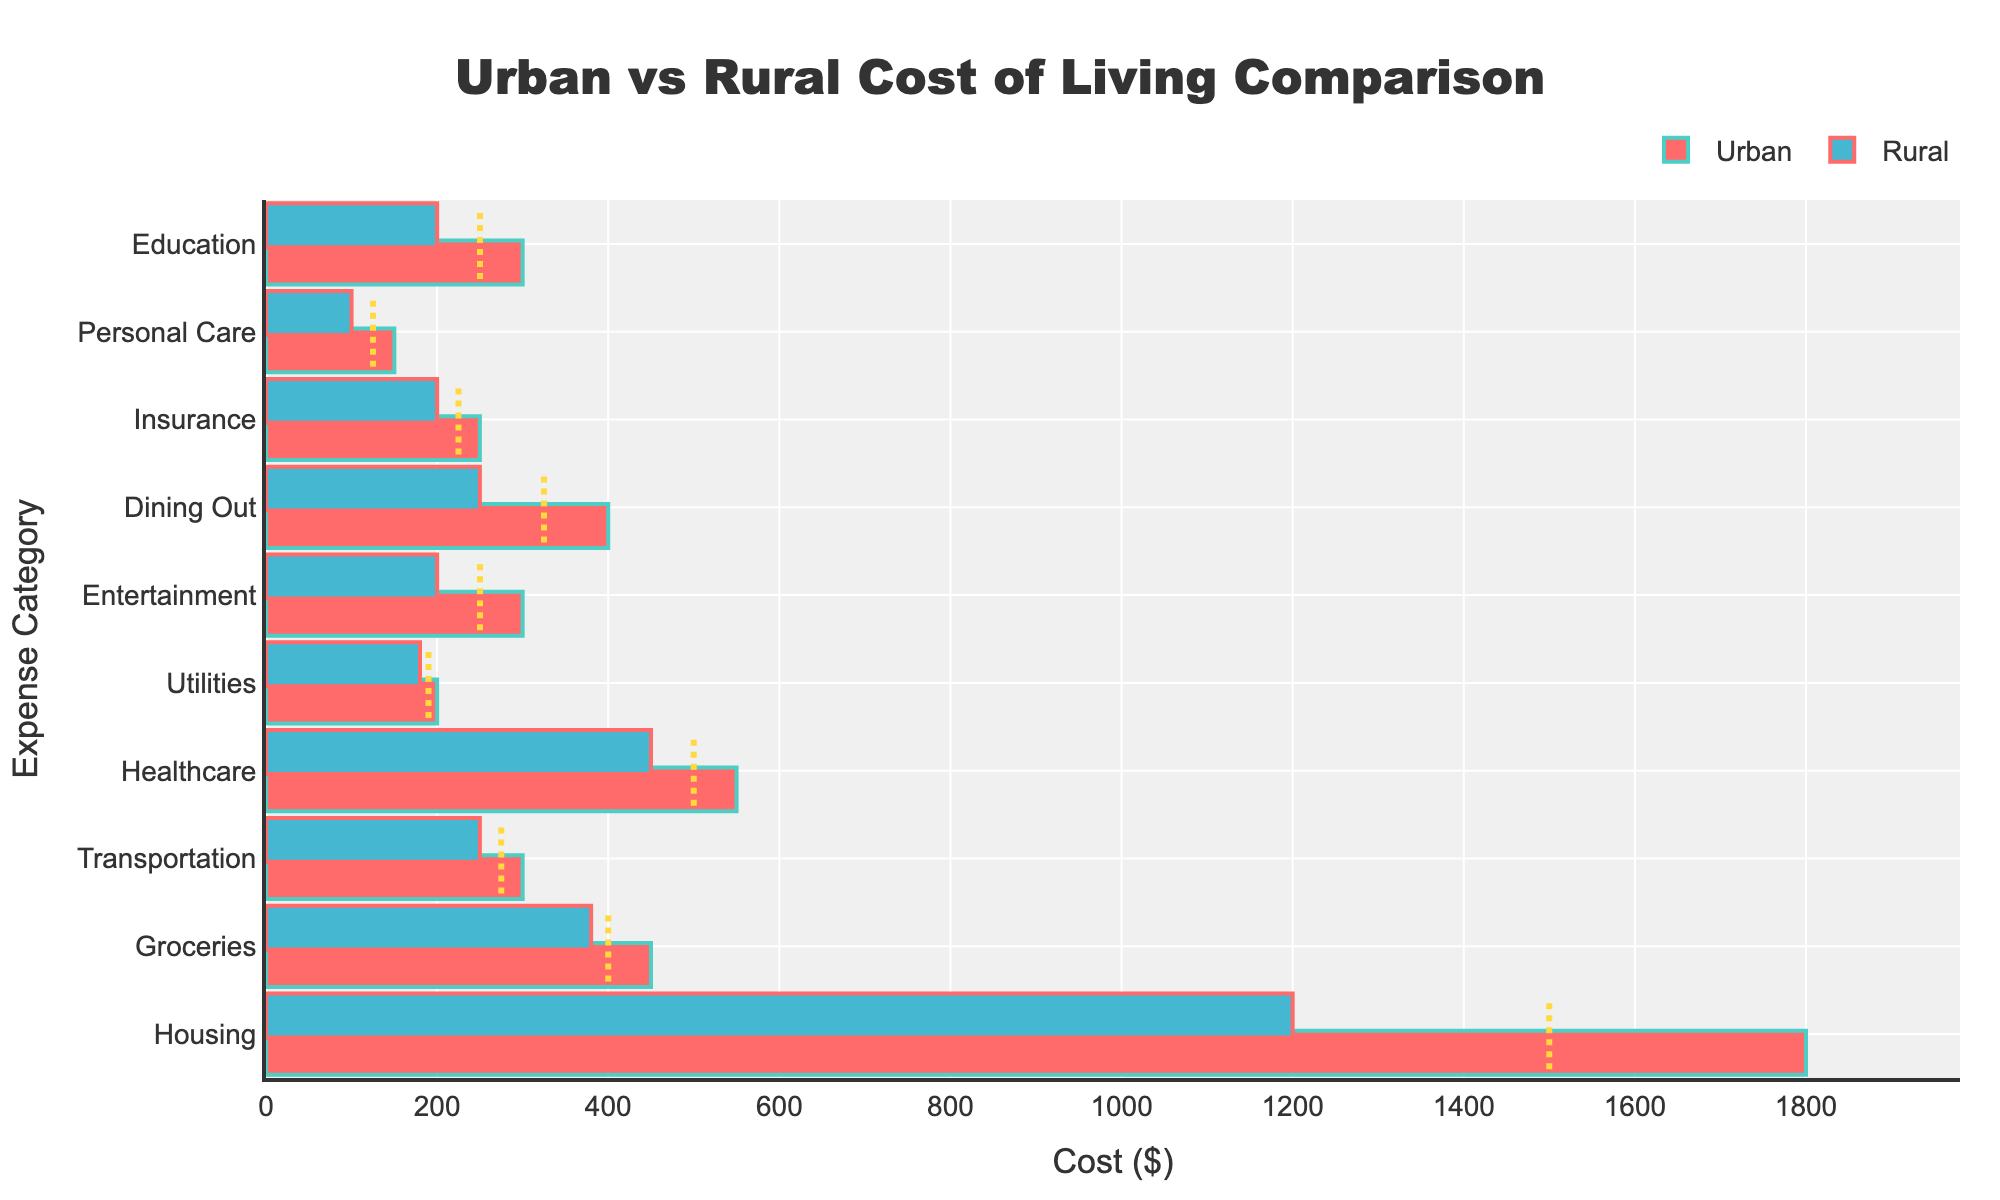what's the title of the figure? The title is located at the top center of the figure and reads "Urban vs Rural Cost of Living Comparison".
Answer: Urban vs Rural Cost of Living Comparison Which category has the largest cost difference between urban and rural areas? To find the largest cost difference, we calculate the absolute difference between urban and rural costs for each category. The largest difference is 600 for Housing, i.e., $1800 (Urban) - $1200 (Rural) = $600.
Answer: Housing What is the average cost of Healthcare in urban and rural areas? The urban cost of Healthcare is $550 and the rural cost is $450. The average is calculated as (550 + 450) / 2 = $500.
Answer: $500 In which category is the urban cost equal to the rural cost? By visually inspecting the bars for each category, there is no category where the costs are equal; every urban cost is higher than its corresponding rural cost.
Answer: None Which category has a rural cost that is exactly on the benchmark? By locating the intersection of the rural bar and the benchmark line, we find that the rural cost for Groceries is $380, which matches the benchmark of $400.
Answer: Groceries How much more is spent on entertainment in urban areas compared to rural areas? The urban cost for Entertainment is $300 and the rural cost is $200. The difference is $300 - $200 = $100.
Answer: $100 Which category's urban cost is closest to the benchmark value? The urban cost for Utilities is $200, which is closest to its benchmark value of $190 compared to other categories.
Answer: Utilities What's the sum of the rural costs for Transportation, Healthcare, and Utilities? Adding the rural costs for these categories: $250 (Transportation) + $450 (Healthcare) + $180 (Utilities) = $880.
Answer: $880 Which expense in urban areas is most aligned with its benchmark value? By observing the alignment between urban bars and associated benchmark lines, we see that the urban cost for Utilities at $200 is closest to its benchmark value of $190.
Answer: Utilities 